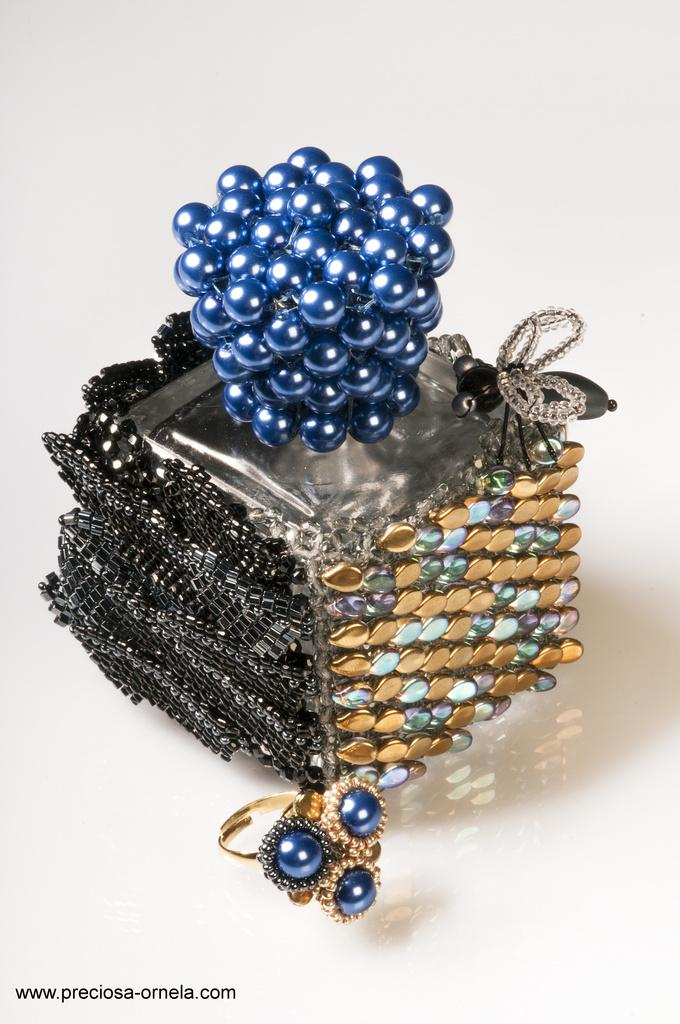What object is present in the image that resembles a container? There is a box in the image. What can be seen at the bottom of the image? There is a ring at the bottom of the image. What type of lace can be seen decorating the box in the image? There is no lace present on the box in the image. How many dimes are visible on the ring at the bottom of the image? There are no dimes present on the ring at the bottom of the image. 